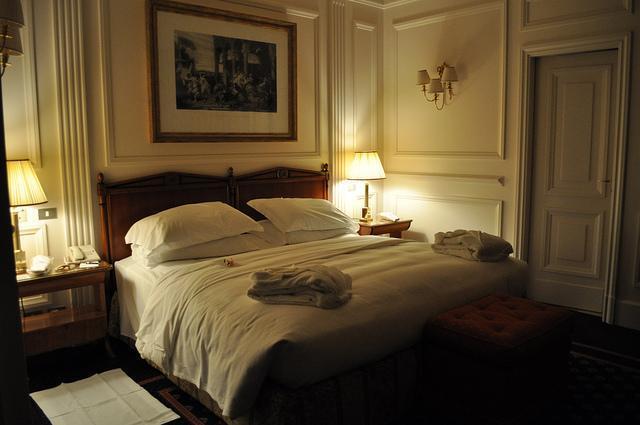How many pillows on the bed?
Give a very brief answer. 4. How many beds are here?
Give a very brief answer. 1. How many framed pictures are on the wall?
Give a very brief answer. 1. How many windows are in the room?
Give a very brief answer. 0. How many fish are on the bed?
Give a very brief answer. 0. How many beds are there?
Give a very brief answer. 1. How many keyboards are shown?
Give a very brief answer. 0. 